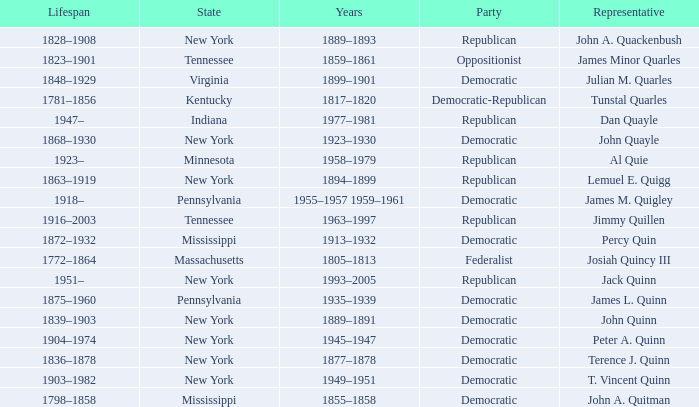What is the lifespan of the democratic party in New York, for which Terence J. Quinn is a representative? 1836–1878. 